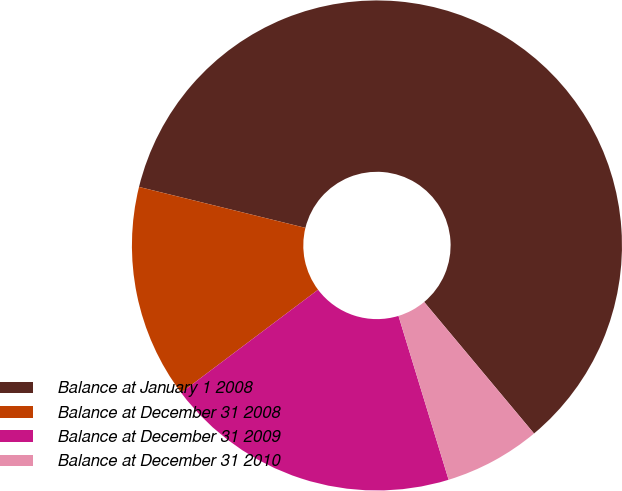<chart> <loc_0><loc_0><loc_500><loc_500><pie_chart><fcel>Balance at January 1 2008<fcel>Balance at December 31 2008<fcel>Balance at December 31 2009<fcel>Balance at December 31 2010<nl><fcel>60.08%<fcel>14.1%<fcel>19.46%<fcel>6.35%<nl></chart> 